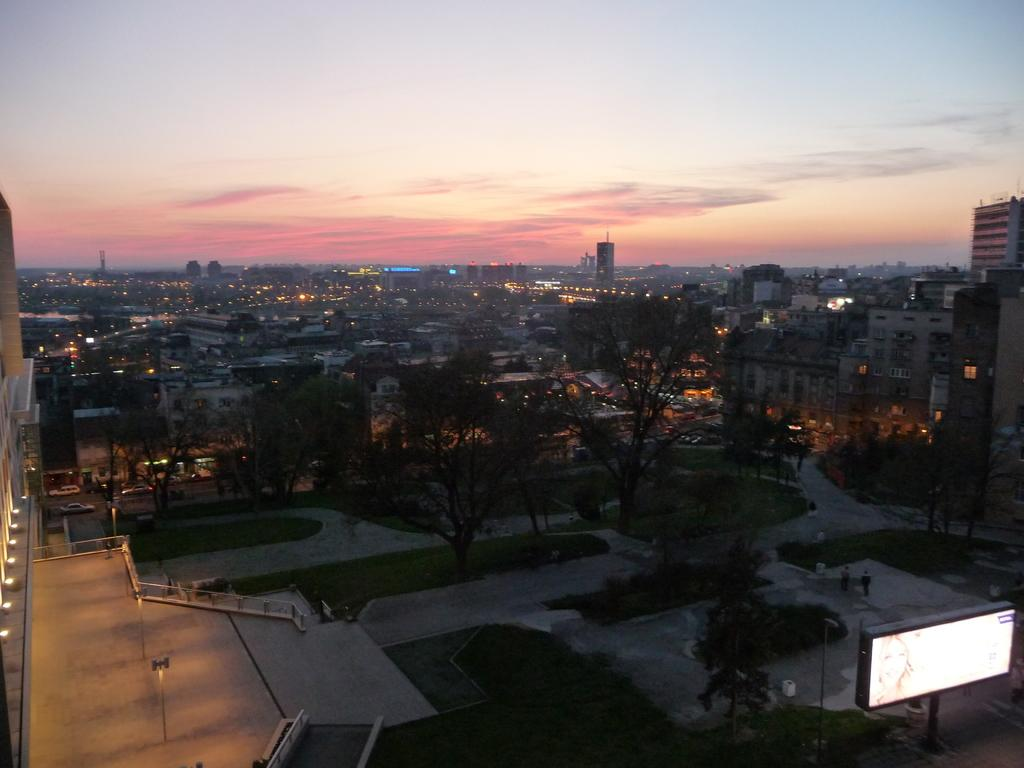What types of structures are present in the image? There are buildings and houses in the image. What natural elements can be seen in the image? There are trees and plants in the image. What man-made elements are present in the image? There are roads in the image. What scent can be detected in the image? There is no information about scents in the image, as it only provides visual details. 